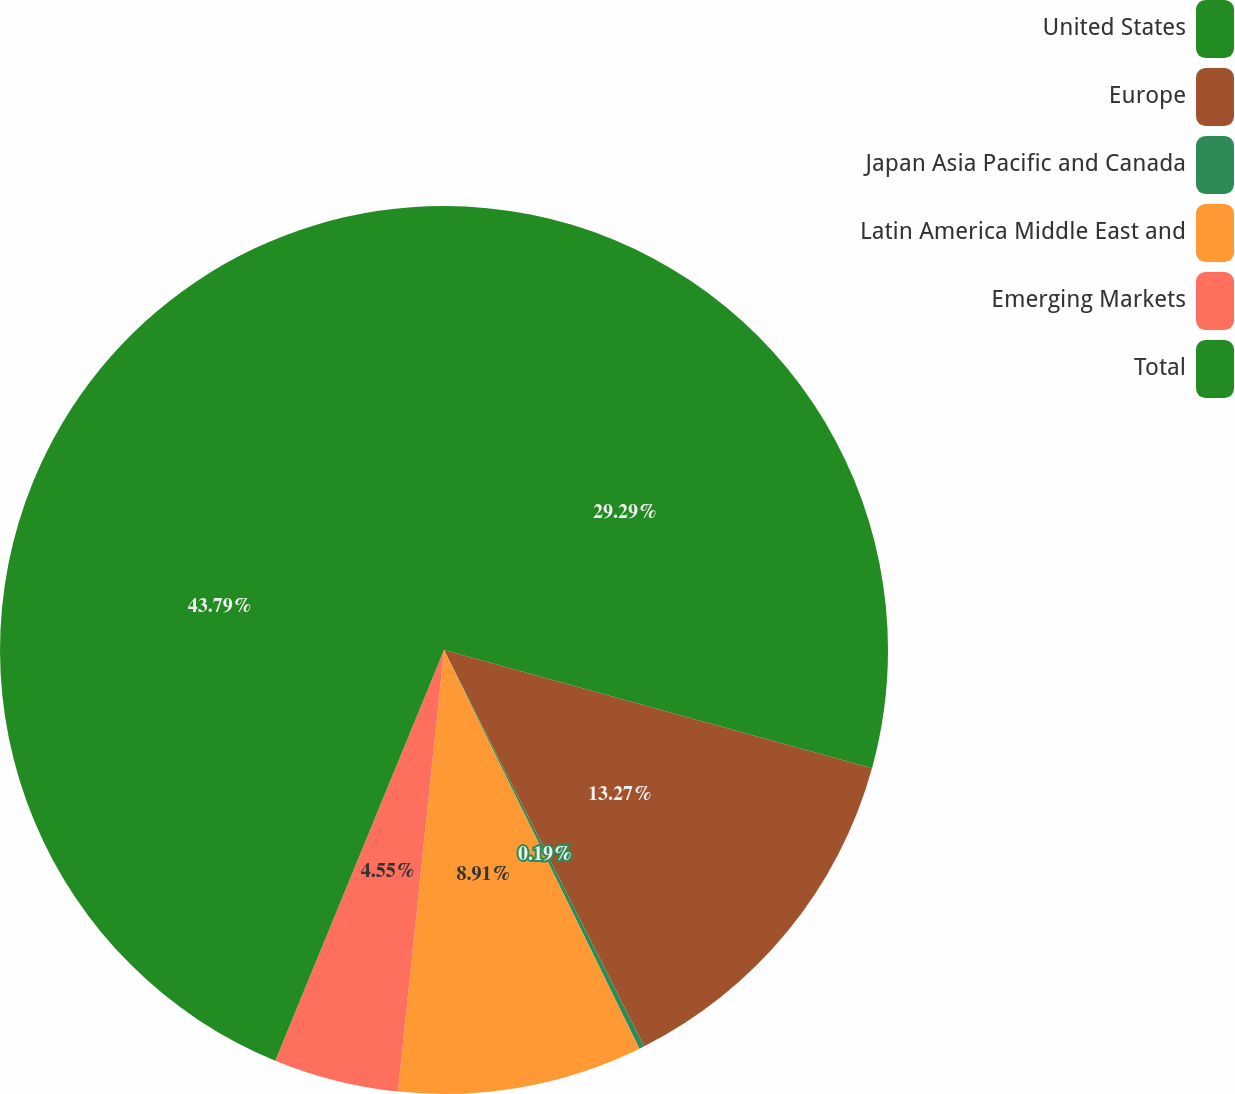Convert chart. <chart><loc_0><loc_0><loc_500><loc_500><pie_chart><fcel>United States<fcel>Europe<fcel>Japan Asia Pacific and Canada<fcel>Latin America Middle East and<fcel>Emerging Markets<fcel>Total<nl><fcel>29.29%<fcel>13.27%<fcel>0.19%<fcel>8.91%<fcel>4.55%<fcel>43.8%<nl></chart> 